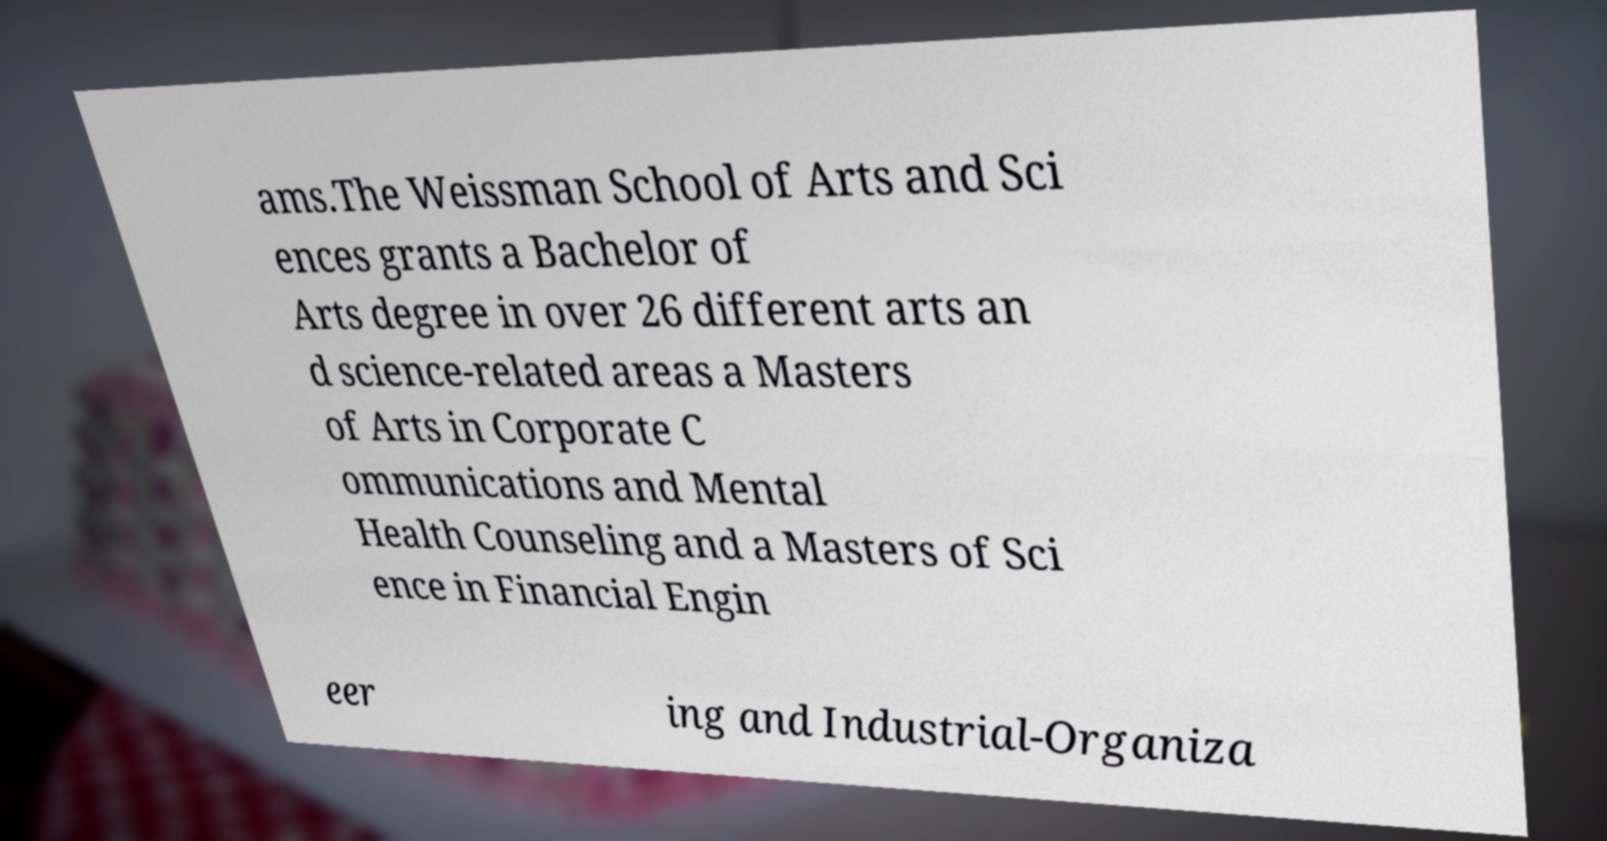Can you accurately transcribe the text from the provided image for me? ams.The Weissman School of Arts and Sci ences grants a Bachelor of Arts degree in over 26 different arts an d science-related areas a Masters of Arts in Corporate C ommunications and Mental Health Counseling and a Masters of Sci ence in Financial Engin eer ing and Industrial-Organiza 